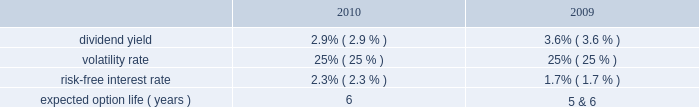Tax benefits recognized for stock-based compensation during the years ended december 31 , 2011 , 2010 and 2009 , were $ 16 million , $ 6 million and $ 5 million , respectively .
The amount of northrop grumman shares issued before the spin-off to satisfy stock-based compensation awards are recorded by northrop grumman and , accordingly , are not reflected in hii 2019s consolidated financial statements .
The company realized tax benefits during the year ended december 31 , 2011 , of $ 2 million from the exercise of stock options and $ 10 million from the issuance of stock in settlement of rpsrs and rsrs .
Unrecognized compensation expense at december 31 , 2011 there was $ 1 million of unrecognized compensation expense related to unvested stock option awards , which will be recognized over a weighted average period of 1.1 years .
In addition , at december 31 , 2011 , there was $ 19 million of unrecognized compensation expense associated with the 2011 rsrs , which will be recognized over a period of 2.2 years ; $ 10 million of unrecognized compensation expense associated with the rpsrs converted as part of the spin-off , which will be recognized over a weighted average period of one year ; and $ 18 million of unrecognized compensation expense associated with the 2011 rpsrs which will be recognized over a period of 2.0 years .
Stock options the compensation expense for the outstanding converted stock options was determined at the time of grant by northrop grumman .
There were no additional options granted during the year ended december 31 , 2011 .
The fair value of the stock option awards is expensed on a straight-line basis over the vesting period of the options .
The fair value of each of the stock option award was estimated on the date of grant using a black-scholes option pricing model based on the following assumptions : dividend yield 2014the dividend yield was based on northrop grumman 2019s historical dividend yield level .
Volatility 2014expected volatility was based on the average of the implied volatility from traded options and the historical volatility of northrop grumman 2019s stock .
Risk-free interest rate 2014the risk-free rate for periods within the contractual life of the stock option award was based on the yield curve of a zero-coupon u.s .
Treasury bond on the date the award was granted with a maturity equal to the expected term of the award .
Expected term 2014the expected term of awards granted was derived from historical experience and represents the period of time that awards granted are expected to be outstanding .
A stratification of expected terms based on employee populations ( executive and non-executive ) was considered in the analysis .
The following significant weighted-average assumptions were used to value stock options granted during the years ended december 31 , 2010 and 2009: .
The weighted-average grant date fair value of stock options granted during the years ended december 31 , 2010 and 2009 , was $ 11 and $ 7 , per share , respectively. .
What is the total tax benefits realized during 2011? 
Computations: (2 + 10)
Answer: 12.0. 